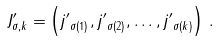Convert formula to latex. <formula><loc_0><loc_0><loc_500><loc_500>J ^ { \prime } _ { \sigma , k } = \left ( { j ^ { \prime } } _ { \sigma ( 1 ) } , { j ^ { \prime } } _ { \sigma ( 2 ) } , \dots , { j ^ { \prime } } _ { \sigma ( k ) } \right ) \, .</formula> 